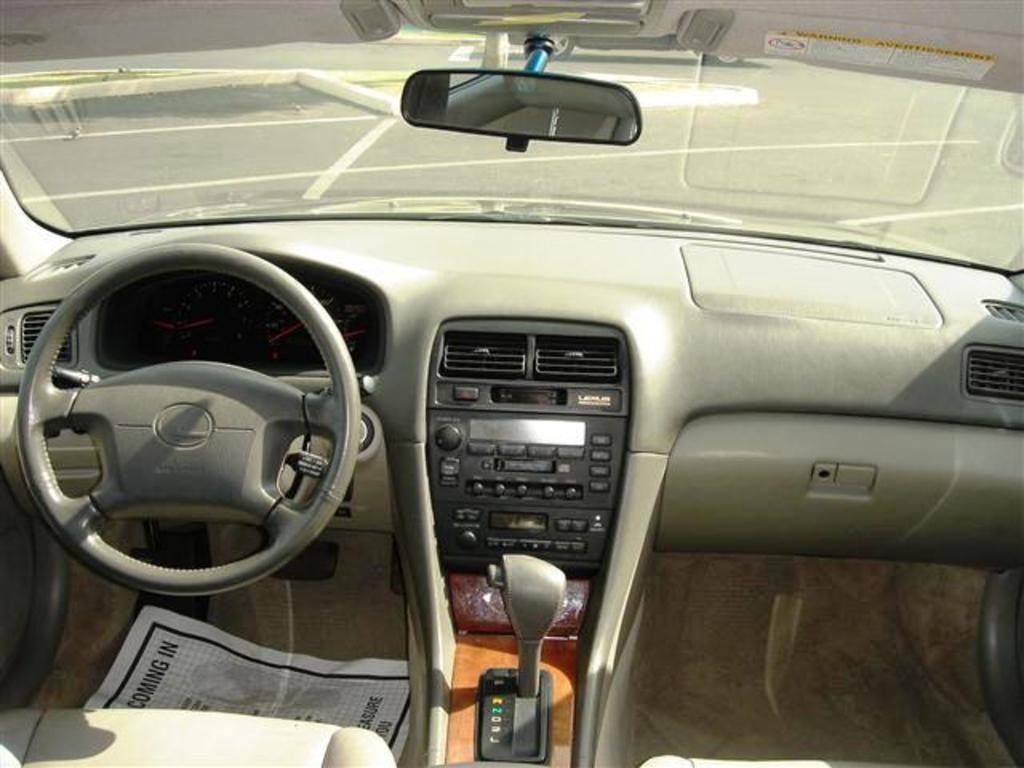How would you summarize this image in a sentence or two? The image is taken inside a car, there is a steering and speedometers, beside that there is a gear rod and some other equipment. 